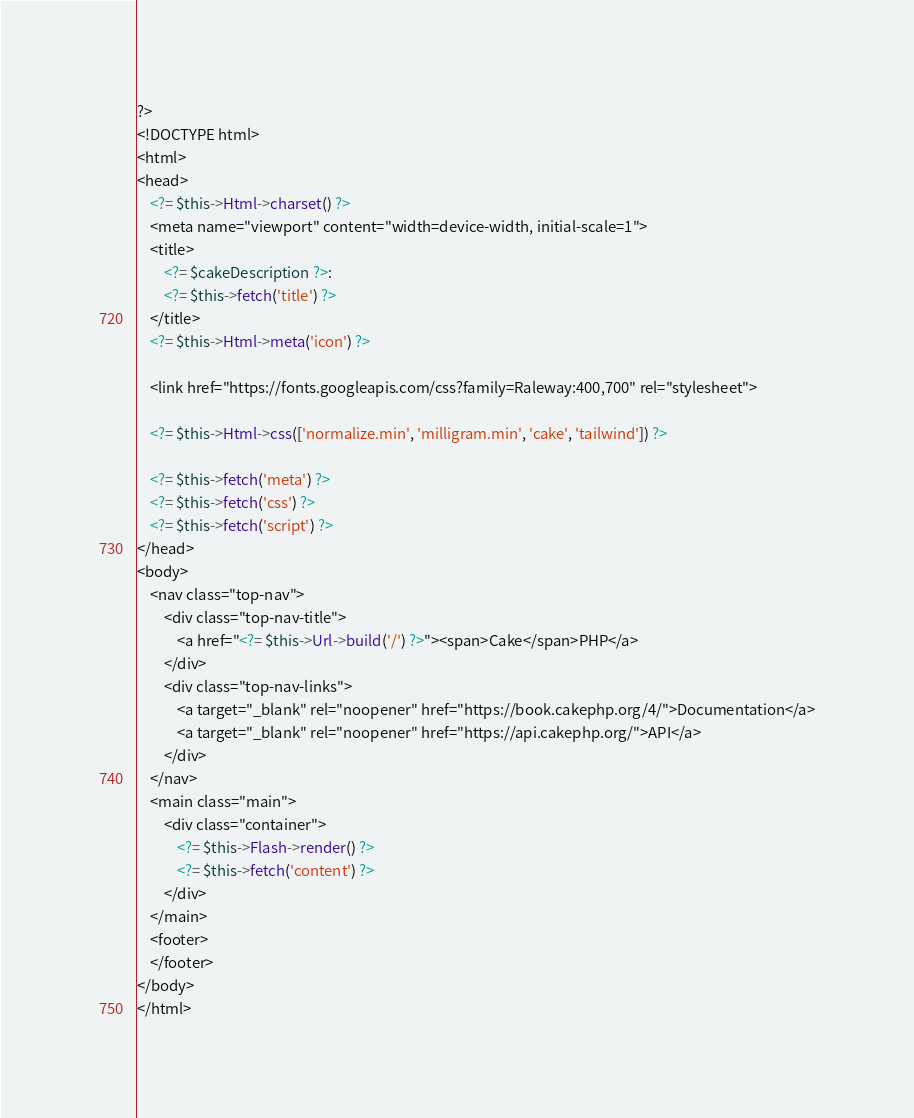<code> <loc_0><loc_0><loc_500><loc_500><_PHP_>?>
<!DOCTYPE html>
<html>
<head>
    <?= $this->Html->charset() ?>
    <meta name="viewport" content="width=device-width, initial-scale=1">
    <title>
        <?= $cakeDescription ?>:
        <?= $this->fetch('title') ?>
    </title>
    <?= $this->Html->meta('icon') ?>

    <link href="https://fonts.googleapis.com/css?family=Raleway:400,700" rel="stylesheet">

    <?= $this->Html->css(['normalize.min', 'milligram.min', 'cake', 'tailwind']) ?>

    <?= $this->fetch('meta') ?>
    <?= $this->fetch('css') ?>
    <?= $this->fetch('script') ?>
</head>
<body>
    <nav class="top-nav">
        <div class="top-nav-title">
            <a href="<?= $this->Url->build('/') ?>"><span>Cake</span>PHP</a>
        </div>
        <div class="top-nav-links">
            <a target="_blank" rel="noopener" href="https://book.cakephp.org/4/">Documentation</a>
            <a target="_blank" rel="noopener" href="https://api.cakephp.org/">API</a>
        </div>
    </nav>
    <main class="main">
        <div class="container">
            <?= $this->Flash->render() ?>
            <?= $this->fetch('content') ?>
        </div>
    </main>
    <footer>
    </footer>
</body>
</html>
</code> 